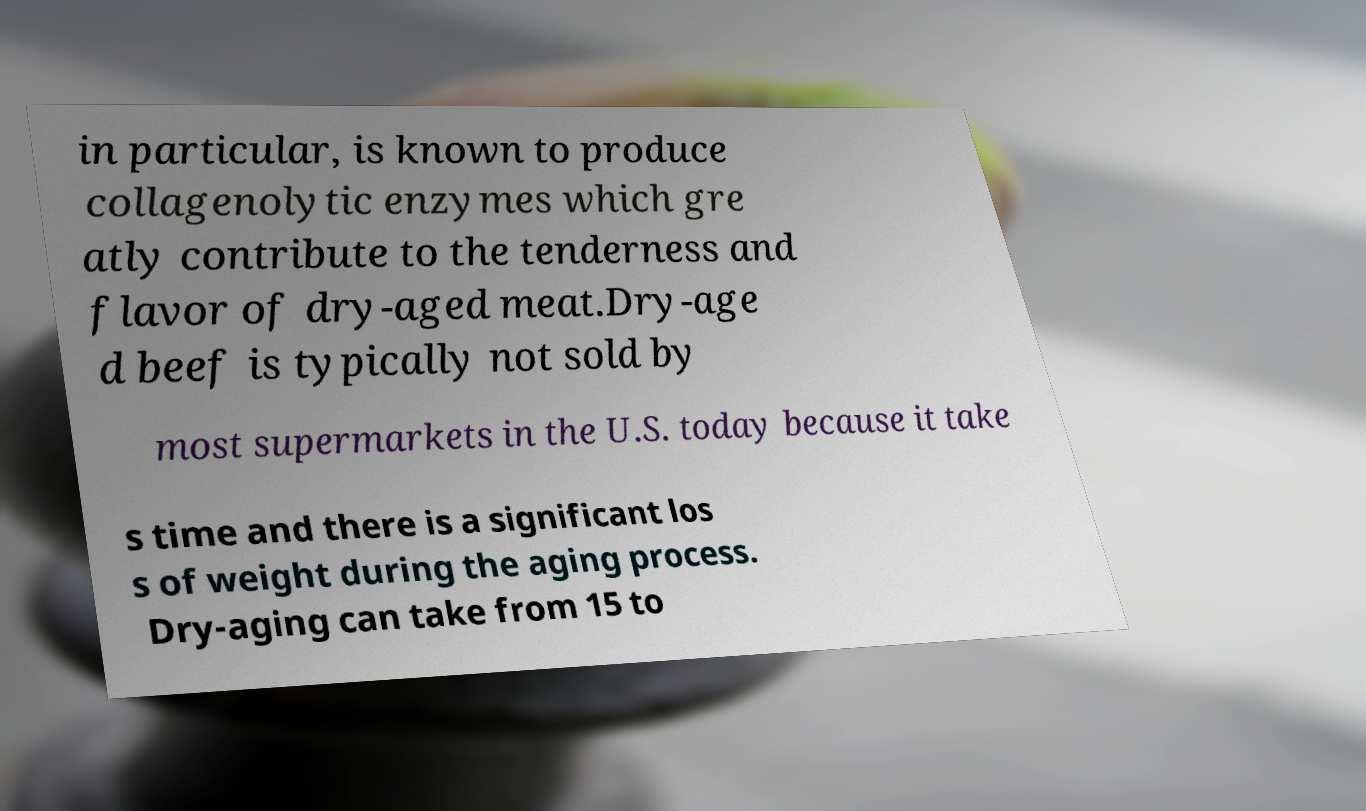For documentation purposes, I need the text within this image transcribed. Could you provide that? in particular, is known to produce collagenolytic enzymes which gre atly contribute to the tenderness and flavor of dry-aged meat.Dry-age d beef is typically not sold by most supermarkets in the U.S. today because it take s time and there is a significant los s of weight during the aging process. Dry-aging can take from 15 to 